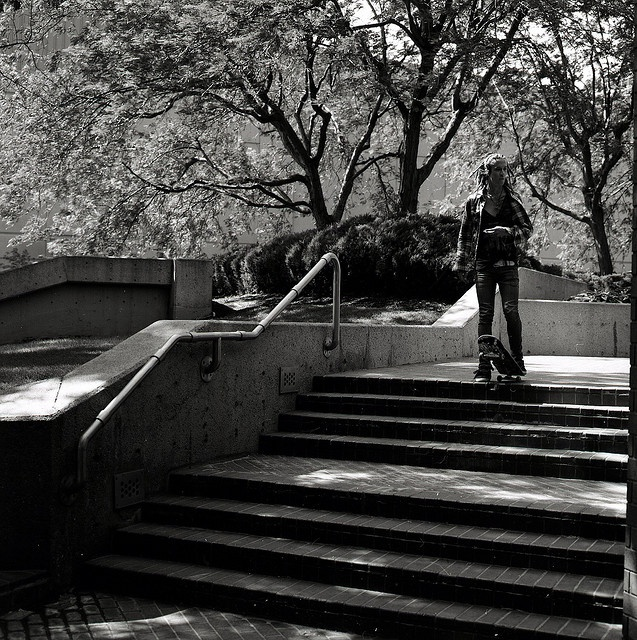Describe the objects in this image and their specific colors. I can see people in black, gray, darkgray, and lightgray tones and skateboard in black, gray, darkgray, and lightgray tones in this image. 